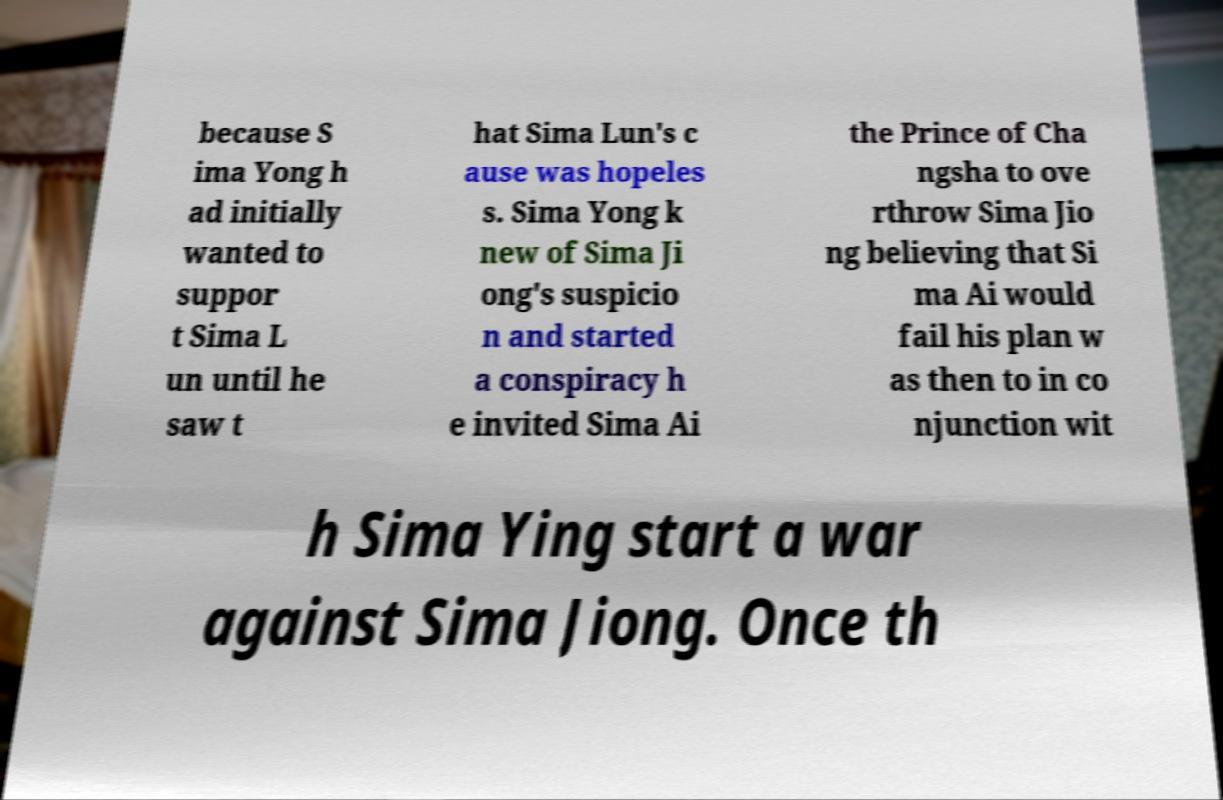Please read and relay the text visible in this image. What does it say? because S ima Yong h ad initially wanted to suppor t Sima L un until he saw t hat Sima Lun's c ause was hopeles s. Sima Yong k new of Sima Ji ong's suspicio n and started a conspiracy h e invited Sima Ai the Prince of Cha ngsha to ove rthrow Sima Jio ng believing that Si ma Ai would fail his plan w as then to in co njunction wit h Sima Ying start a war against Sima Jiong. Once th 